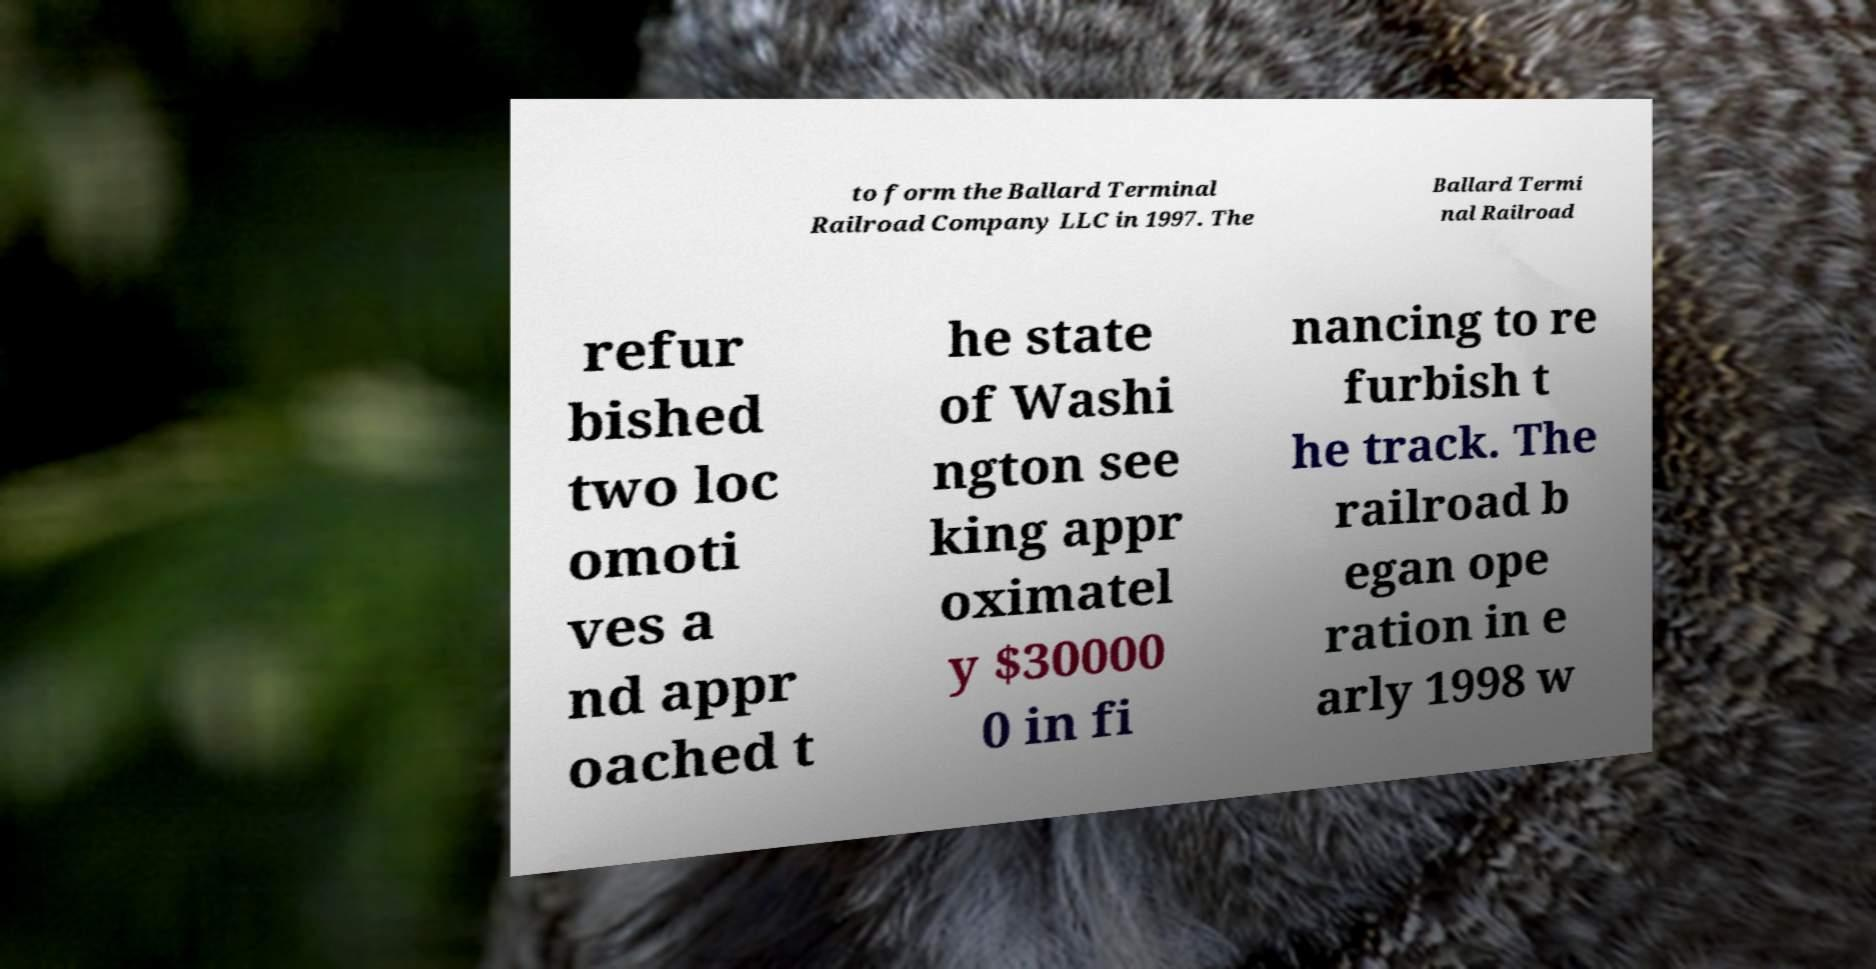What messages or text are displayed in this image? I need them in a readable, typed format. to form the Ballard Terminal Railroad Company LLC in 1997. The Ballard Termi nal Railroad refur bished two loc omoti ves a nd appr oached t he state of Washi ngton see king appr oximatel y $30000 0 in fi nancing to re furbish t he track. The railroad b egan ope ration in e arly 1998 w 